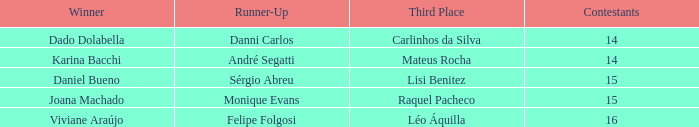How many contestants were there when the runner-up was Sérgio Abreu?  15.0. 